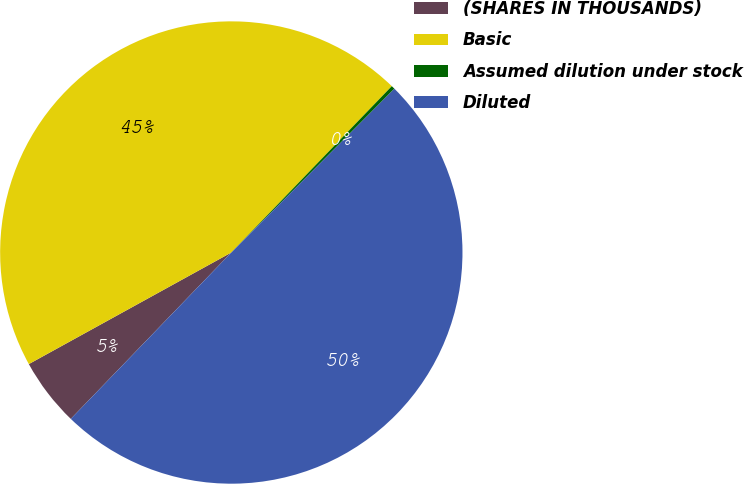Convert chart. <chart><loc_0><loc_0><loc_500><loc_500><pie_chart><fcel>(SHARES IN THOUSANDS)<fcel>Basic<fcel>Assumed dilution under stock<fcel>Diluted<nl><fcel>4.77%<fcel>45.23%<fcel>0.25%<fcel>49.75%<nl></chart> 